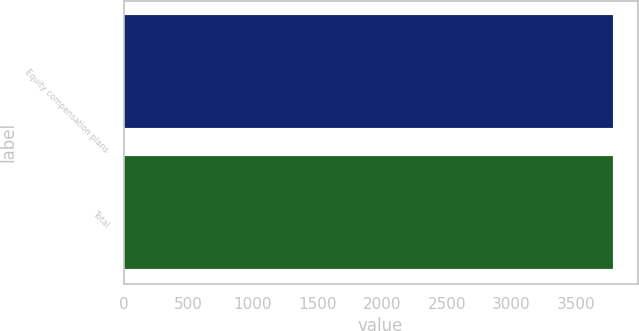<chart> <loc_0><loc_0><loc_500><loc_500><bar_chart><fcel>Equity compensation plans<fcel>Total<nl><fcel>3787<fcel>3787.1<nl></chart> 